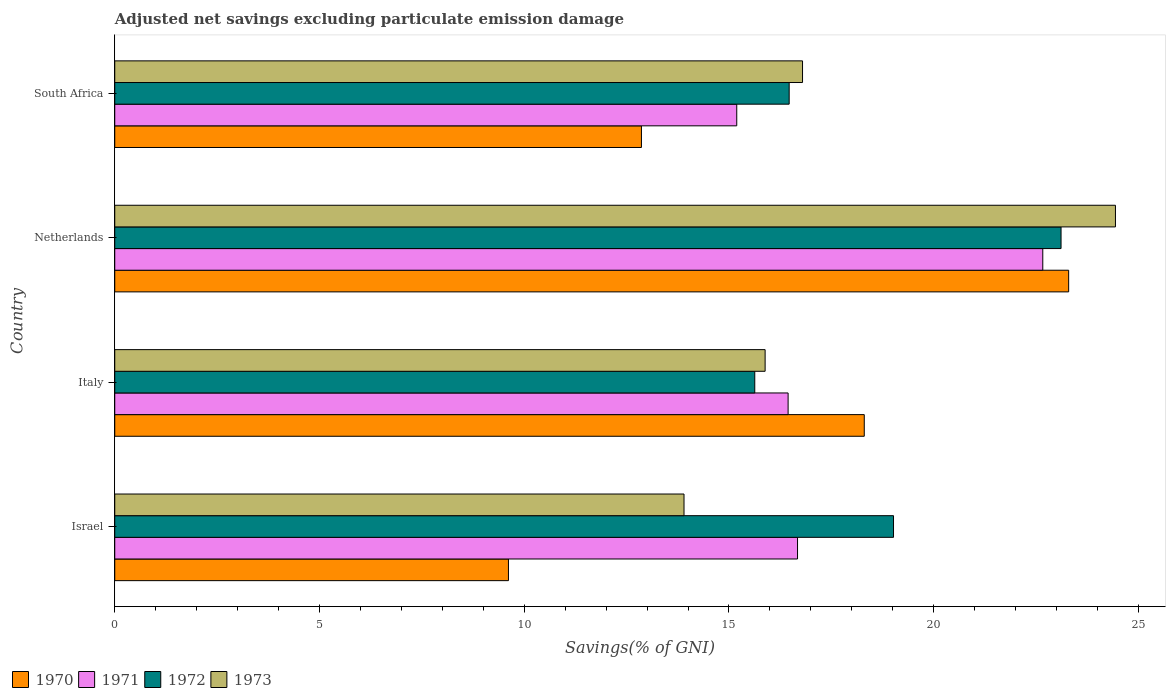How many different coloured bars are there?
Provide a succinct answer. 4. How many groups of bars are there?
Give a very brief answer. 4. What is the label of the 1st group of bars from the top?
Keep it short and to the point. South Africa. In how many cases, is the number of bars for a given country not equal to the number of legend labels?
Make the answer very short. 0. What is the adjusted net savings in 1973 in Israel?
Your response must be concise. 13.9. Across all countries, what is the maximum adjusted net savings in 1973?
Your answer should be very brief. 24.44. Across all countries, what is the minimum adjusted net savings in 1972?
Your response must be concise. 15.63. In which country was the adjusted net savings in 1971 maximum?
Offer a terse response. Netherlands. In which country was the adjusted net savings in 1970 minimum?
Provide a short and direct response. Israel. What is the total adjusted net savings in 1973 in the graph?
Ensure brevity in your answer.  71.02. What is the difference between the adjusted net savings in 1971 in Israel and that in South Africa?
Keep it short and to the point. 1.48. What is the difference between the adjusted net savings in 1970 in Israel and the adjusted net savings in 1971 in Netherlands?
Your answer should be very brief. -13.05. What is the average adjusted net savings in 1972 per country?
Give a very brief answer. 18.56. What is the difference between the adjusted net savings in 1973 and adjusted net savings in 1972 in Israel?
Your response must be concise. -5.12. What is the ratio of the adjusted net savings in 1972 in Italy to that in Netherlands?
Ensure brevity in your answer.  0.68. What is the difference between the highest and the second highest adjusted net savings in 1972?
Provide a succinct answer. 4.09. What is the difference between the highest and the lowest adjusted net savings in 1970?
Ensure brevity in your answer.  13.68. What does the 2nd bar from the bottom in Italy represents?
Your response must be concise. 1971. Is it the case that in every country, the sum of the adjusted net savings in 1973 and adjusted net savings in 1971 is greater than the adjusted net savings in 1970?
Your response must be concise. Yes. Are all the bars in the graph horizontal?
Offer a terse response. Yes. How many countries are there in the graph?
Your answer should be compact. 4. What is the difference between two consecutive major ticks on the X-axis?
Provide a short and direct response. 5. Are the values on the major ticks of X-axis written in scientific E-notation?
Provide a short and direct response. No. Does the graph contain any zero values?
Give a very brief answer. No. Does the graph contain grids?
Provide a succinct answer. No. Where does the legend appear in the graph?
Your response must be concise. Bottom left. How many legend labels are there?
Make the answer very short. 4. How are the legend labels stacked?
Your response must be concise. Horizontal. What is the title of the graph?
Your answer should be very brief. Adjusted net savings excluding particulate emission damage. What is the label or title of the X-axis?
Your answer should be compact. Savings(% of GNI). What is the Savings(% of GNI) in 1970 in Israel?
Provide a succinct answer. 9.61. What is the Savings(% of GNI) in 1971 in Israel?
Provide a short and direct response. 16.67. What is the Savings(% of GNI) in 1972 in Israel?
Your answer should be compact. 19.02. What is the Savings(% of GNI) of 1973 in Israel?
Keep it short and to the point. 13.9. What is the Savings(% of GNI) of 1970 in Italy?
Ensure brevity in your answer.  18.3. What is the Savings(% of GNI) in 1971 in Italy?
Offer a terse response. 16.44. What is the Savings(% of GNI) in 1972 in Italy?
Your answer should be very brief. 15.63. What is the Savings(% of GNI) of 1973 in Italy?
Keep it short and to the point. 15.88. What is the Savings(% of GNI) in 1970 in Netherlands?
Keep it short and to the point. 23.3. What is the Savings(% of GNI) in 1971 in Netherlands?
Provide a succinct answer. 22.66. What is the Savings(% of GNI) of 1972 in Netherlands?
Make the answer very short. 23.11. What is the Savings(% of GNI) in 1973 in Netherlands?
Provide a succinct answer. 24.44. What is the Savings(% of GNI) in 1970 in South Africa?
Offer a terse response. 12.86. What is the Savings(% of GNI) of 1971 in South Africa?
Keep it short and to the point. 15.19. What is the Savings(% of GNI) of 1972 in South Africa?
Provide a succinct answer. 16.47. What is the Savings(% of GNI) in 1973 in South Africa?
Give a very brief answer. 16.8. Across all countries, what is the maximum Savings(% of GNI) in 1970?
Your response must be concise. 23.3. Across all countries, what is the maximum Savings(% of GNI) in 1971?
Give a very brief answer. 22.66. Across all countries, what is the maximum Savings(% of GNI) in 1972?
Your response must be concise. 23.11. Across all countries, what is the maximum Savings(% of GNI) of 1973?
Offer a very short reply. 24.44. Across all countries, what is the minimum Savings(% of GNI) in 1970?
Your answer should be very brief. 9.61. Across all countries, what is the minimum Savings(% of GNI) of 1971?
Ensure brevity in your answer.  15.19. Across all countries, what is the minimum Savings(% of GNI) in 1972?
Ensure brevity in your answer.  15.63. Across all countries, what is the minimum Savings(% of GNI) of 1973?
Ensure brevity in your answer.  13.9. What is the total Savings(% of GNI) in 1970 in the graph?
Make the answer very short. 64.08. What is the total Savings(% of GNI) of 1971 in the graph?
Ensure brevity in your answer.  70.97. What is the total Savings(% of GNI) in 1972 in the graph?
Provide a succinct answer. 74.23. What is the total Savings(% of GNI) of 1973 in the graph?
Your answer should be very brief. 71.02. What is the difference between the Savings(% of GNI) in 1970 in Israel and that in Italy?
Make the answer very short. -8.69. What is the difference between the Savings(% of GNI) of 1971 in Israel and that in Italy?
Your response must be concise. 0.23. What is the difference between the Savings(% of GNI) of 1972 in Israel and that in Italy?
Your response must be concise. 3.39. What is the difference between the Savings(% of GNI) in 1973 in Israel and that in Italy?
Your response must be concise. -1.98. What is the difference between the Savings(% of GNI) in 1970 in Israel and that in Netherlands?
Offer a terse response. -13.68. What is the difference between the Savings(% of GNI) of 1971 in Israel and that in Netherlands?
Give a very brief answer. -5.99. What is the difference between the Savings(% of GNI) in 1972 in Israel and that in Netherlands?
Provide a succinct answer. -4.09. What is the difference between the Savings(% of GNI) of 1973 in Israel and that in Netherlands?
Your answer should be very brief. -10.54. What is the difference between the Savings(% of GNI) in 1970 in Israel and that in South Africa?
Offer a very short reply. -3.25. What is the difference between the Savings(% of GNI) of 1971 in Israel and that in South Africa?
Keep it short and to the point. 1.48. What is the difference between the Savings(% of GNI) in 1972 in Israel and that in South Africa?
Provide a succinct answer. 2.55. What is the difference between the Savings(% of GNI) of 1973 in Israel and that in South Africa?
Your response must be concise. -2.89. What is the difference between the Savings(% of GNI) of 1970 in Italy and that in Netherlands?
Offer a very short reply. -4.99. What is the difference between the Savings(% of GNI) in 1971 in Italy and that in Netherlands?
Make the answer very short. -6.22. What is the difference between the Savings(% of GNI) of 1972 in Italy and that in Netherlands?
Offer a terse response. -7.48. What is the difference between the Savings(% of GNI) of 1973 in Italy and that in Netherlands?
Offer a very short reply. -8.56. What is the difference between the Savings(% of GNI) in 1970 in Italy and that in South Africa?
Keep it short and to the point. 5.44. What is the difference between the Savings(% of GNI) of 1971 in Italy and that in South Africa?
Your answer should be compact. 1.25. What is the difference between the Savings(% of GNI) of 1972 in Italy and that in South Africa?
Offer a very short reply. -0.84. What is the difference between the Savings(% of GNI) of 1973 in Italy and that in South Africa?
Provide a short and direct response. -0.91. What is the difference between the Savings(% of GNI) in 1970 in Netherlands and that in South Africa?
Your answer should be compact. 10.43. What is the difference between the Savings(% of GNI) of 1971 in Netherlands and that in South Africa?
Your response must be concise. 7.47. What is the difference between the Savings(% of GNI) of 1972 in Netherlands and that in South Africa?
Offer a terse response. 6.64. What is the difference between the Savings(% of GNI) of 1973 in Netherlands and that in South Africa?
Make the answer very short. 7.64. What is the difference between the Savings(% of GNI) in 1970 in Israel and the Savings(% of GNI) in 1971 in Italy?
Keep it short and to the point. -6.83. What is the difference between the Savings(% of GNI) in 1970 in Israel and the Savings(% of GNI) in 1972 in Italy?
Give a very brief answer. -6.02. What is the difference between the Savings(% of GNI) in 1970 in Israel and the Savings(% of GNI) in 1973 in Italy?
Your response must be concise. -6.27. What is the difference between the Savings(% of GNI) in 1971 in Israel and the Savings(% of GNI) in 1972 in Italy?
Your answer should be very brief. 1.04. What is the difference between the Savings(% of GNI) of 1971 in Israel and the Savings(% of GNI) of 1973 in Italy?
Offer a very short reply. 0.79. What is the difference between the Savings(% of GNI) of 1972 in Israel and the Savings(% of GNI) of 1973 in Italy?
Keep it short and to the point. 3.14. What is the difference between the Savings(% of GNI) of 1970 in Israel and the Savings(% of GNI) of 1971 in Netherlands?
Offer a terse response. -13.05. What is the difference between the Savings(% of GNI) in 1970 in Israel and the Savings(% of GNI) in 1972 in Netherlands?
Give a very brief answer. -13.49. What is the difference between the Savings(% of GNI) of 1970 in Israel and the Savings(% of GNI) of 1973 in Netherlands?
Provide a succinct answer. -14.82. What is the difference between the Savings(% of GNI) of 1971 in Israel and the Savings(% of GNI) of 1972 in Netherlands?
Your answer should be very brief. -6.44. What is the difference between the Savings(% of GNI) in 1971 in Israel and the Savings(% of GNI) in 1973 in Netherlands?
Provide a short and direct response. -7.76. What is the difference between the Savings(% of GNI) in 1972 in Israel and the Savings(% of GNI) in 1973 in Netherlands?
Provide a short and direct response. -5.42. What is the difference between the Savings(% of GNI) in 1970 in Israel and the Savings(% of GNI) in 1971 in South Africa?
Keep it short and to the point. -5.58. What is the difference between the Savings(% of GNI) of 1970 in Israel and the Savings(% of GNI) of 1972 in South Africa?
Keep it short and to the point. -6.86. What is the difference between the Savings(% of GNI) in 1970 in Israel and the Savings(% of GNI) in 1973 in South Africa?
Your answer should be compact. -7.18. What is the difference between the Savings(% of GNI) of 1971 in Israel and the Savings(% of GNI) of 1972 in South Africa?
Provide a short and direct response. 0.2. What is the difference between the Savings(% of GNI) in 1971 in Israel and the Savings(% of GNI) in 1973 in South Africa?
Keep it short and to the point. -0.12. What is the difference between the Savings(% of GNI) of 1972 in Israel and the Savings(% of GNI) of 1973 in South Africa?
Your response must be concise. 2.22. What is the difference between the Savings(% of GNI) in 1970 in Italy and the Savings(% of GNI) in 1971 in Netherlands?
Make the answer very short. -4.36. What is the difference between the Savings(% of GNI) in 1970 in Italy and the Savings(% of GNI) in 1972 in Netherlands?
Offer a very short reply. -4.81. What is the difference between the Savings(% of GNI) in 1970 in Italy and the Savings(% of GNI) in 1973 in Netherlands?
Keep it short and to the point. -6.13. What is the difference between the Savings(% of GNI) of 1971 in Italy and the Savings(% of GNI) of 1972 in Netherlands?
Make the answer very short. -6.67. What is the difference between the Savings(% of GNI) of 1971 in Italy and the Savings(% of GNI) of 1973 in Netherlands?
Keep it short and to the point. -7.99. What is the difference between the Savings(% of GNI) of 1972 in Italy and the Savings(% of GNI) of 1973 in Netherlands?
Provide a short and direct response. -8.81. What is the difference between the Savings(% of GNI) in 1970 in Italy and the Savings(% of GNI) in 1971 in South Africa?
Make the answer very short. 3.11. What is the difference between the Savings(% of GNI) of 1970 in Italy and the Savings(% of GNI) of 1972 in South Africa?
Give a very brief answer. 1.83. What is the difference between the Savings(% of GNI) in 1970 in Italy and the Savings(% of GNI) in 1973 in South Africa?
Give a very brief answer. 1.51. What is the difference between the Savings(% of GNI) in 1971 in Italy and the Savings(% of GNI) in 1972 in South Africa?
Provide a succinct answer. -0.03. What is the difference between the Savings(% of GNI) in 1971 in Italy and the Savings(% of GNI) in 1973 in South Africa?
Your response must be concise. -0.35. What is the difference between the Savings(% of GNI) in 1972 in Italy and the Savings(% of GNI) in 1973 in South Africa?
Give a very brief answer. -1.17. What is the difference between the Savings(% of GNI) in 1970 in Netherlands and the Savings(% of GNI) in 1971 in South Africa?
Your response must be concise. 8.11. What is the difference between the Savings(% of GNI) in 1970 in Netherlands and the Savings(% of GNI) in 1972 in South Africa?
Keep it short and to the point. 6.83. What is the difference between the Savings(% of GNI) of 1970 in Netherlands and the Savings(% of GNI) of 1973 in South Africa?
Offer a very short reply. 6.5. What is the difference between the Savings(% of GNI) in 1971 in Netherlands and the Savings(% of GNI) in 1972 in South Africa?
Make the answer very short. 6.19. What is the difference between the Savings(% of GNI) in 1971 in Netherlands and the Savings(% of GNI) in 1973 in South Africa?
Provide a short and direct response. 5.87. What is the difference between the Savings(% of GNI) of 1972 in Netherlands and the Savings(% of GNI) of 1973 in South Africa?
Offer a terse response. 6.31. What is the average Savings(% of GNI) in 1970 per country?
Offer a terse response. 16.02. What is the average Savings(% of GNI) in 1971 per country?
Provide a short and direct response. 17.74. What is the average Savings(% of GNI) of 1972 per country?
Make the answer very short. 18.56. What is the average Savings(% of GNI) in 1973 per country?
Make the answer very short. 17.75. What is the difference between the Savings(% of GNI) of 1970 and Savings(% of GNI) of 1971 in Israel?
Make the answer very short. -7.06. What is the difference between the Savings(% of GNI) of 1970 and Savings(% of GNI) of 1972 in Israel?
Your answer should be very brief. -9.4. What is the difference between the Savings(% of GNI) in 1970 and Savings(% of GNI) in 1973 in Israel?
Your response must be concise. -4.29. What is the difference between the Savings(% of GNI) in 1971 and Savings(% of GNI) in 1972 in Israel?
Provide a succinct answer. -2.34. What is the difference between the Savings(% of GNI) of 1971 and Savings(% of GNI) of 1973 in Israel?
Your response must be concise. 2.77. What is the difference between the Savings(% of GNI) of 1972 and Savings(% of GNI) of 1973 in Israel?
Your answer should be compact. 5.12. What is the difference between the Savings(% of GNI) of 1970 and Savings(% of GNI) of 1971 in Italy?
Your answer should be compact. 1.86. What is the difference between the Savings(% of GNI) in 1970 and Savings(% of GNI) in 1972 in Italy?
Your response must be concise. 2.67. What is the difference between the Savings(% of GNI) in 1970 and Savings(% of GNI) in 1973 in Italy?
Ensure brevity in your answer.  2.42. What is the difference between the Savings(% of GNI) of 1971 and Savings(% of GNI) of 1972 in Italy?
Offer a terse response. 0.81. What is the difference between the Savings(% of GNI) in 1971 and Savings(% of GNI) in 1973 in Italy?
Your answer should be very brief. 0.56. What is the difference between the Savings(% of GNI) of 1972 and Savings(% of GNI) of 1973 in Italy?
Provide a succinct answer. -0.25. What is the difference between the Savings(% of GNI) in 1970 and Savings(% of GNI) in 1971 in Netherlands?
Your answer should be very brief. 0.63. What is the difference between the Savings(% of GNI) in 1970 and Savings(% of GNI) in 1972 in Netherlands?
Your response must be concise. 0.19. What is the difference between the Savings(% of GNI) of 1970 and Savings(% of GNI) of 1973 in Netherlands?
Offer a very short reply. -1.14. What is the difference between the Savings(% of GNI) of 1971 and Savings(% of GNI) of 1972 in Netherlands?
Your response must be concise. -0.45. What is the difference between the Savings(% of GNI) of 1971 and Savings(% of GNI) of 1973 in Netherlands?
Your answer should be very brief. -1.77. What is the difference between the Savings(% of GNI) in 1972 and Savings(% of GNI) in 1973 in Netherlands?
Give a very brief answer. -1.33. What is the difference between the Savings(% of GNI) in 1970 and Savings(% of GNI) in 1971 in South Africa?
Ensure brevity in your answer.  -2.33. What is the difference between the Savings(% of GNI) of 1970 and Savings(% of GNI) of 1972 in South Africa?
Offer a very short reply. -3.61. What is the difference between the Savings(% of GNI) of 1970 and Savings(% of GNI) of 1973 in South Africa?
Your answer should be very brief. -3.93. What is the difference between the Savings(% of GNI) in 1971 and Savings(% of GNI) in 1972 in South Africa?
Your answer should be very brief. -1.28. What is the difference between the Savings(% of GNI) of 1971 and Savings(% of GNI) of 1973 in South Africa?
Your response must be concise. -1.61. What is the difference between the Savings(% of GNI) in 1972 and Savings(% of GNI) in 1973 in South Africa?
Your response must be concise. -0.33. What is the ratio of the Savings(% of GNI) in 1970 in Israel to that in Italy?
Ensure brevity in your answer.  0.53. What is the ratio of the Savings(% of GNI) of 1972 in Israel to that in Italy?
Your answer should be compact. 1.22. What is the ratio of the Savings(% of GNI) of 1973 in Israel to that in Italy?
Your answer should be compact. 0.88. What is the ratio of the Savings(% of GNI) in 1970 in Israel to that in Netherlands?
Your answer should be very brief. 0.41. What is the ratio of the Savings(% of GNI) of 1971 in Israel to that in Netherlands?
Your answer should be compact. 0.74. What is the ratio of the Savings(% of GNI) of 1972 in Israel to that in Netherlands?
Ensure brevity in your answer.  0.82. What is the ratio of the Savings(% of GNI) in 1973 in Israel to that in Netherlands?
Offer a terse response. 0.57. What is the ratio of the Savings(% of GNI) in 1970 in Israel to that in South Africa?
Keep it short and to the point. 0.75. What is the ratio of the Savings(% of GNI) of 1971 in Israel to that in South Africa?
Keep it short and to the point. 1.1. What is the ratio of the Savings(% of GNI) in 1972 in Israel to that in South Africa?
Ensure brevity in your answer.  1.15. What is the ratio of the Savings(% of GNI) in 1973 in Israel to that in South Africa?
Provide a succinct answer. 0.83. What is the ratio of the Savings(% of GNI) in 1970 in Italy to that in Netherlands?
Ensure brevity in your answer.  0.79. What is the ratio of the Savings(% of GNI) of 1971 in Italy to that in Netherlands?
Provide a short and direct response. 0.73. What is the ratio of the Savings(% of GNI) of 1972 in Italy to that in Netherlands?
Offer a terse response. 0.68. What is the ratio of the Savings(% of GNI) in 1973 in Italy to that in Netherlands?
Offer a very short reply. 0.65. What is the ratio of the Savings(% of GNI) of 1970 in Italy to that in South Africa?
Make the answer very short. 1.42. What is the ratio of the Savings(% of GNI) in 1971 in Italy to that in South Africa?
Offer a terse response. 1.08. What is the ratio of the Savings(% of GNI) in 1972 in Italy to that in South Africa?
Your answer should be very brief. 0.95. What is the ratio of the Savings(% of GNI) of 1973 in Italy to that in South Africa?
Provide a short and direct response. 0.95. What is the ratio of the Savings(% of GNI) of 1970 in Netherlands to that in South Africa?
Provide a succinct answer. 1.81. What is the ratio of the Savings(% of GNI) in 1971 in Netherlands to that in South Africa?
Your response must be concise. 1.49. What is the ratio of the Savings(% of GNI) of 1972 in Netherlands to that in South Africa?
Provide a succinct answer. 1.4. What is the ratio of the Savings(% of GNI) of 1973 in Netherlands to that in South Africa?
Provide a short and direct response. 1.46. What is the difference between the highest and the second highest Savings(% of GNI) in 1970?
Your response must be concise. 4.99. What is the difference between the highest and the second highest Savings(% of GNI) of 1971?
Offer a terse response. 5.99. What is the difference between the highest and the second highest Savings(% of GNI) in 1972?
Your response must be concise. 4.09. What is the difference between the highest and the second highest Savings(% of GNI) of 1973?
Give a very brief answer. 7.64. What is the difference between the highest and the lowest Savings(% of GNI) of 1970?
Offer a very short reply. 13.68. What is the difference between the highest and the lowest Savings(% of GNI) in 1971?
Keep it short and to the point. 7.47. What is the difference between the highest and the lowest Savings(% of GNI) in 1972?
Your response must be concise. 7.48. What is the difference between the highest and the lowest Savings(% of GNI) in 1973?
Provide a succinct answer. 10.54. 